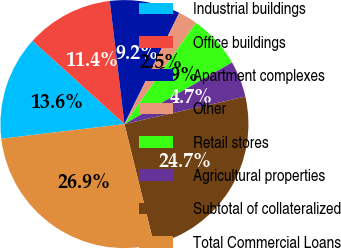Convert chart to OTSL. <chart><loc_0><loc_0><loc_500><loc_500><pie_chart><fcel>Industrial buildings<fcel>Office buildings<fcel>Apartment complexes<fcel>Other<fcel>Retail stores<fcel>Agricultural properties<fcel>Subtotal of collateralized<fcel>Total Commercial Loans<nl><fcel>13.61%<fcel>11.39%<fcel>9.17%<fcel>2.5%<fcel>6.94%<fcel>4.72%<fcel>24.73%<fcel>26.95%<nl></chart> 